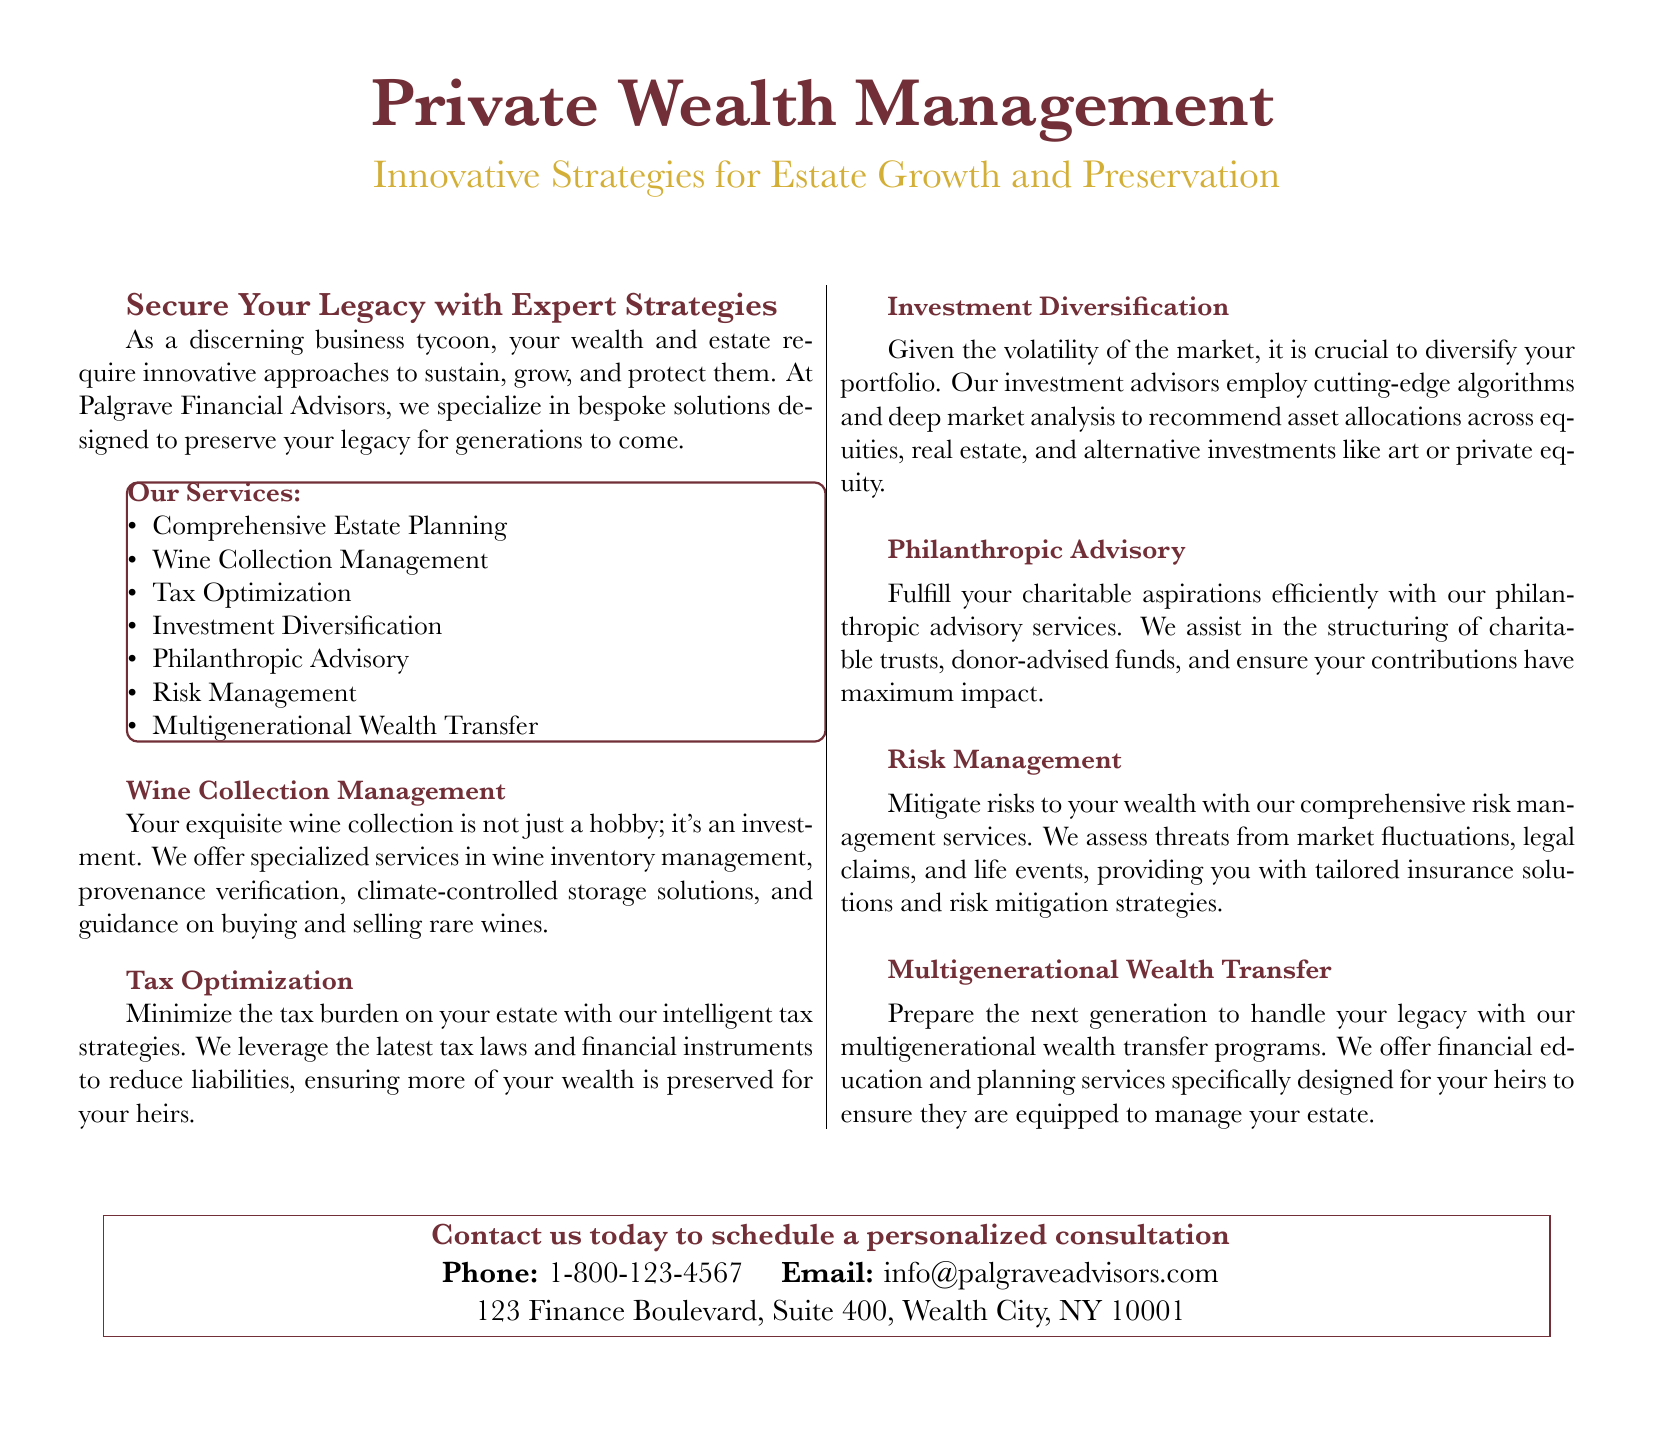What is the main focus of Palgrave Financial Advisors? The main focus is to provide innovative approaches to sustain, grow, and protect wealth and estate.
Answer: Innovative approaches to sustain, grow, and protect What type of management is offered for wine collections? The document states that specialized services are provided for wine inventory management and related needs.
Answer: Wine Inventory Management What is one of the services listed under risk management? The document mentions tailored insurance solutions as a method to mitigate risks to wealth.
Answer: Tailored insurance solutions Which service is aimed at the next generation regarding wealth? It refers to programs specifically designed for heirs in managing the estate.
Answer: Multigenerational Wealth Transfer Why should one consider tax optimization strategies? The reason given is to minimize the tax burden on an estate and preserve wealth for heirs.
Answer: Minimize the tax burden What aspect does tax optimization focus on? The document emphasizes reducing liabilities through the latest tax laws and financial instruments.
Answer: Reducing liabilities Which strategy helps diversify a portfolio according to the document? The document cites employing cutting-edge algorithms and deep market analysis for investment diversification strategies.
Answer: Cutting-edge algorithms 